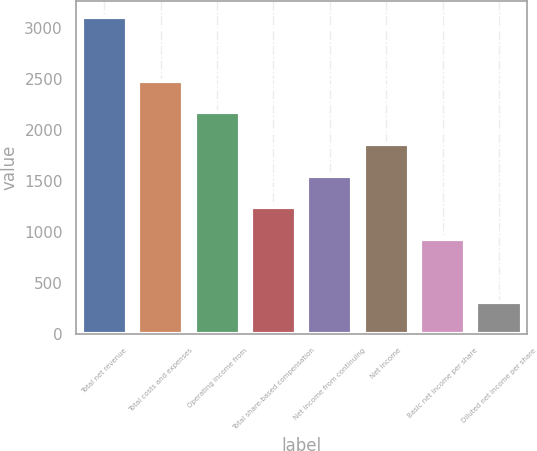<chart> <loc_0><loc_0><loc_500><loc_500><bar_chart><fcel>Total net revenue<fcel>Total costs and expenses<fcel>Operating income from<fcel>Total share-based compensation<fcel>Net income from continuing<fcel>Net income<fcel>Basic net income per share<fcel>Diluted net income per share<nl><fcel>3109<fcel>2487.46<fcel>2176.7<fcel>1244.4<fcel>1555.17<fcel>1865.94<fcel>933.64<fcel>312.12<nl></chart> 